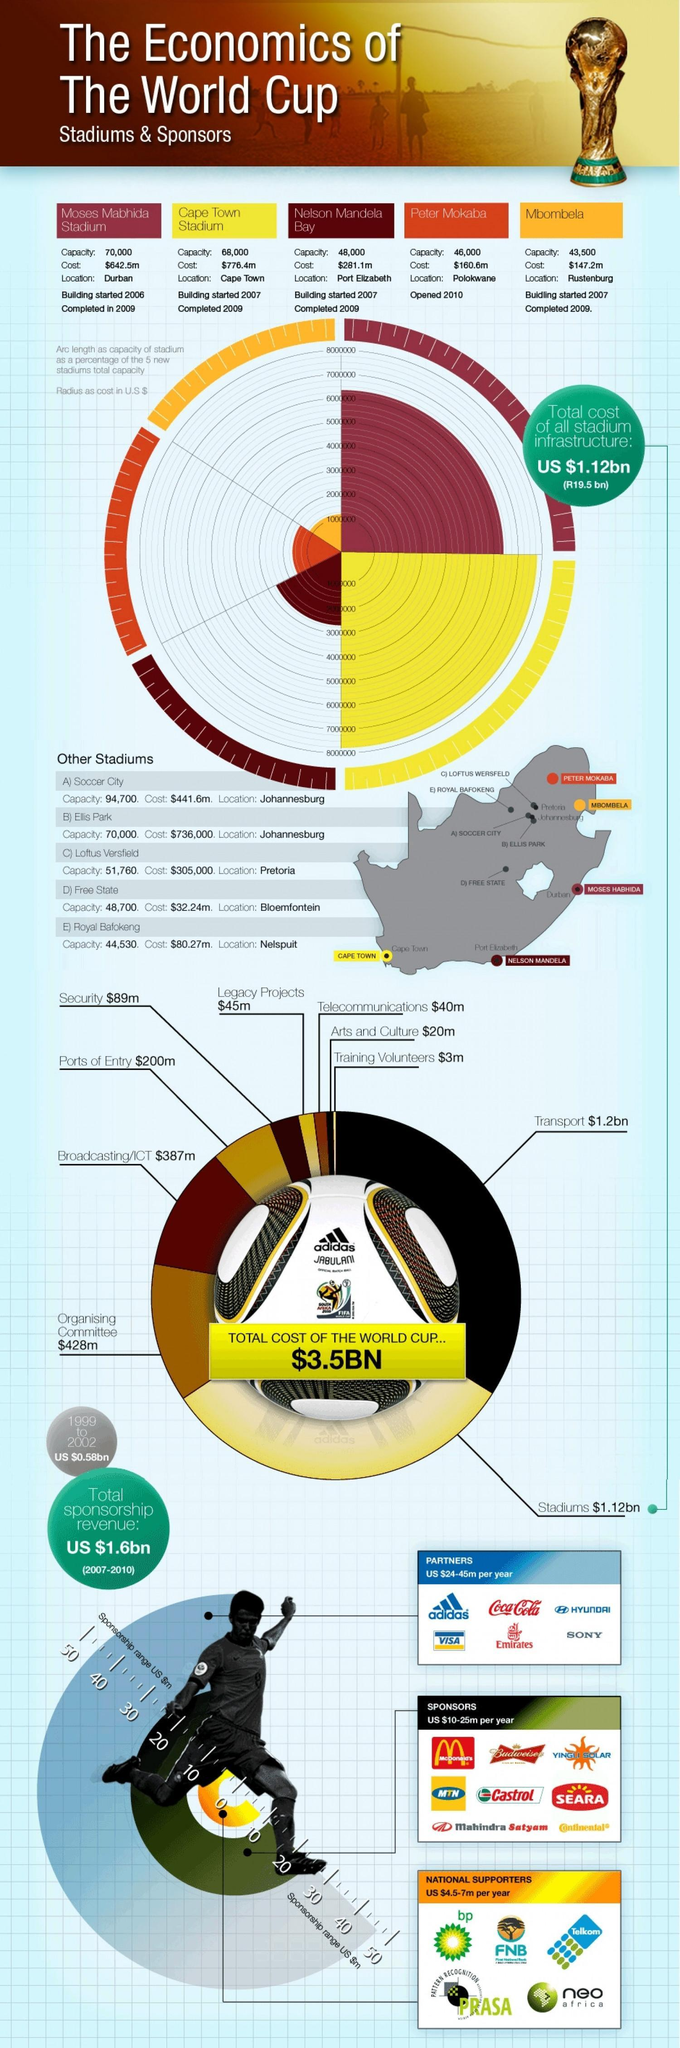When did the stadium with a capacity of 46,000 start functioning?
Answer the question with a short phrase. 2010 Which stadium was expensive to build among the ones mentioned? Cape Town Stadium Where is the stadium with maximum capacity located? Durban Which stadiums were started in 2007 and completed in 2009? Cape Town Stadium, Nelson Mandela Bay, Mbombela 